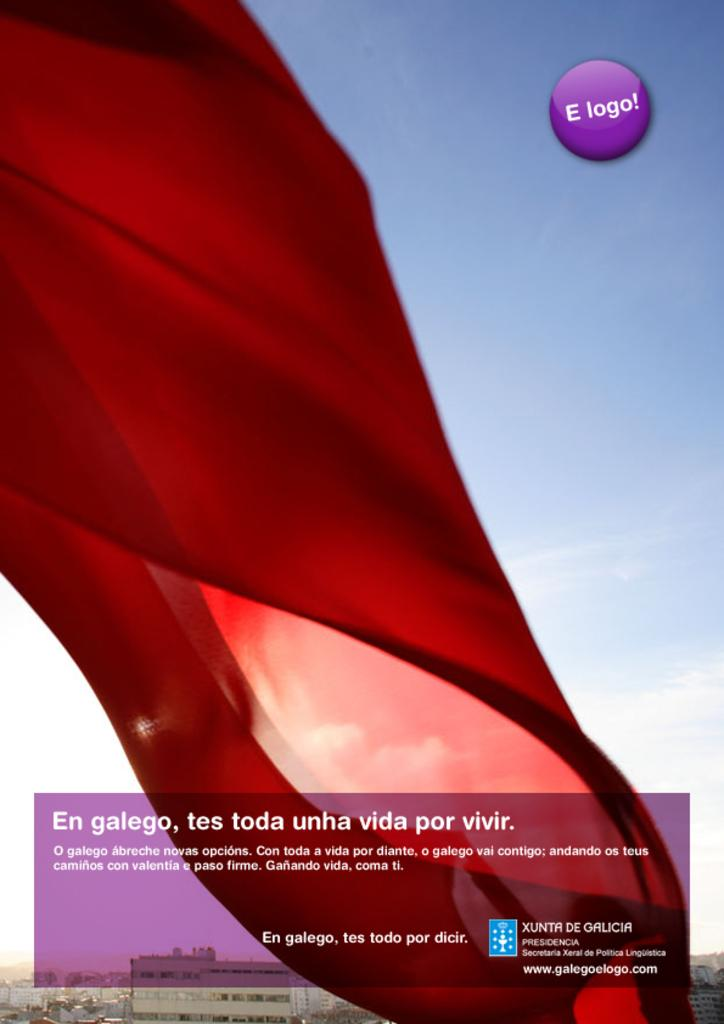<image>
Provide a brief description of the given image. Screen showing a red banner in front of a sky and the word "E Logo!" on it. 